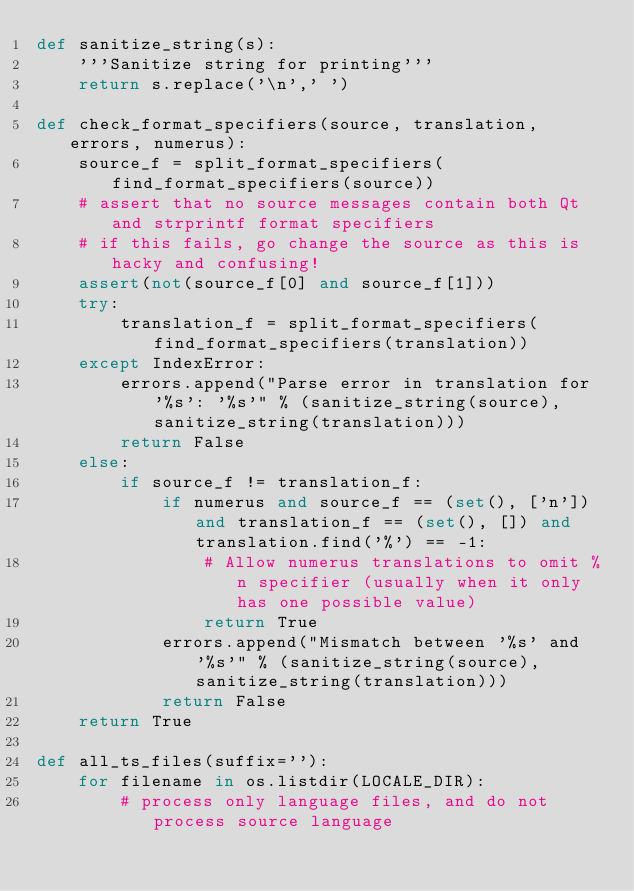<code> <loc_0><loc_0><loc_500><loc_500><_Python_>def sanitize_string(s):
    '''Sanitize string for printing'''
    return s.replace('\n',' ')

def check_format_specifiers(source, translation, errors, numerus):
    source_f = split_format_specifiers(find_format_specifiers(source))
    # assert that no source messages contain both Qt and strprintf format specifiers
    # if this fails, go change the source as this is hacky and confusing!
    assert(not(source_f[0] and source_f[1]))
    try:
        translation_f = split_format_specifiers(find_format_specifiers(translation))
    except IndexError:
        errors.append("Parse error in translation for '%s': '%s'" % (sanitize_string(source), sanitize_string(translation)))
        return False
    else:
        if source_f != translation_f:
            if numerus and source_f == (set(), ['n']) and translation_f == (set(), []) and translation.find('%') == -1:
                # Allow numerus translations to omit %n specifier (usually when it only has one possible value)
                return True
            errors.append("Mismatch between '%s' and '%s'" % (sanitize_string(source), sanitize_string(translation)))
            return False
    return True

def all_ts_files(suffix=''):
    for filename in os.listdir(LOCALE_DIR):
        # process only language files, and do not process source language</code> 